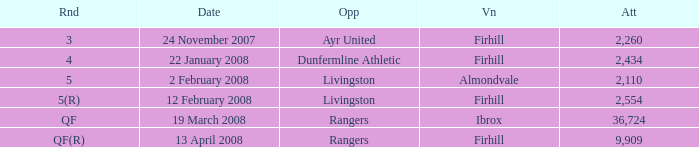What is the average attendance at a game held at Firhill for the 5(r) round? 2554.0. 